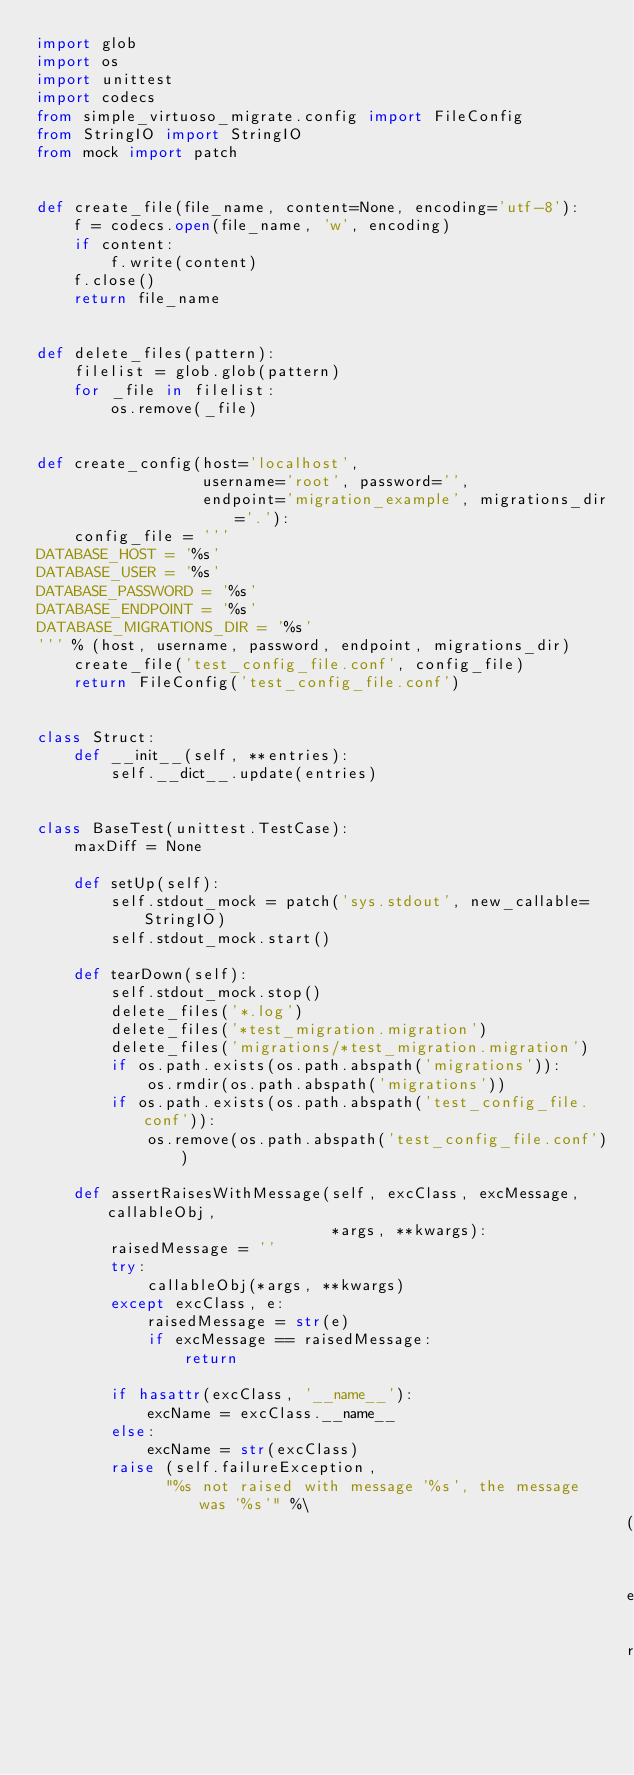Convert code to text. <code><loc_0><loc_0><loc_500><loc_500><_Python_>import glob
import os
import unittest
import codecs
from simple_virtuoso_migrate.config import FileConfig
from StringIO import StringIO
from mock import patch


def create_file(file_name, content=None, encoding='utf-8'):
    f = codecs.open(file_name, 'w', encoding)
    if content:
        f.write(content)
    f.close()
    return file_name


def delete_files(pattern):
    filelist = glob.glob(pattern)
    for _file in filelist:
        os.remove(_file)


def create_config(host='localhost',
                  username='root', password='',
                  endpoint='migration_example', migrations_dir='.'):
    config_file = '''
DATABASE_HOST = '%s'
DATABASE_USER = '%s'
DATABASE_PASSWORD = '%s'
DATABASE_ENDPOINT = '%s'
DATABASE_MIGRATIONS_DIR = '%s'
''' % (host, username, password, endpoint, migrations_dir)
    create_file('test_config_file.conf', config_file)
    return FileConfig('test_config_file.conf')


class Struct:
    def __init__(self, **entries):
        self.__dict__.update(entries)


class BaseTest(unittest.TestCase):
    maxDiff = None

    def setUp(self):
        self.stdout_mock = patch('sys.stdout', new_callable=StringIO)
        self.stdout_mock.start()

    def tearDown(self):
        self.stdout_mock.stop()
        delete_files('*.log')
        delete_files('*test_migration.migration')
        delete_files('migrations/*test_migration.migration')
        if os.path.exists(os.path.abspath('migrations')):
            os.rmdir(os.path.abspath('migrations'))
        if os.path.exists(os.path.abspath('test_config_file.conf')):
            os.remove(os.path.abspath('test_config_file.conf'))

    def assertRaisesWithMessage(self, excClass, excMessage, callableObj,
                                *args, **kwargs):
        raisedMessage = ''
        try:
            callableObj(*args, **kwargs)
        except excClass, e:
            raisedMessage = str(e)
            if excMessage == raisedMessage:
                return

        if hasattr(excClass, '__name__'):
            excName = excClass.__name__
        else:
            excName = str(excClass)
        raise (self.failureException,
              "%s not raised with message '%s', the message was '%s'" %\
                                                                (excName,
                                                                excMessage,
                                                                raisedMessage))
</code> 